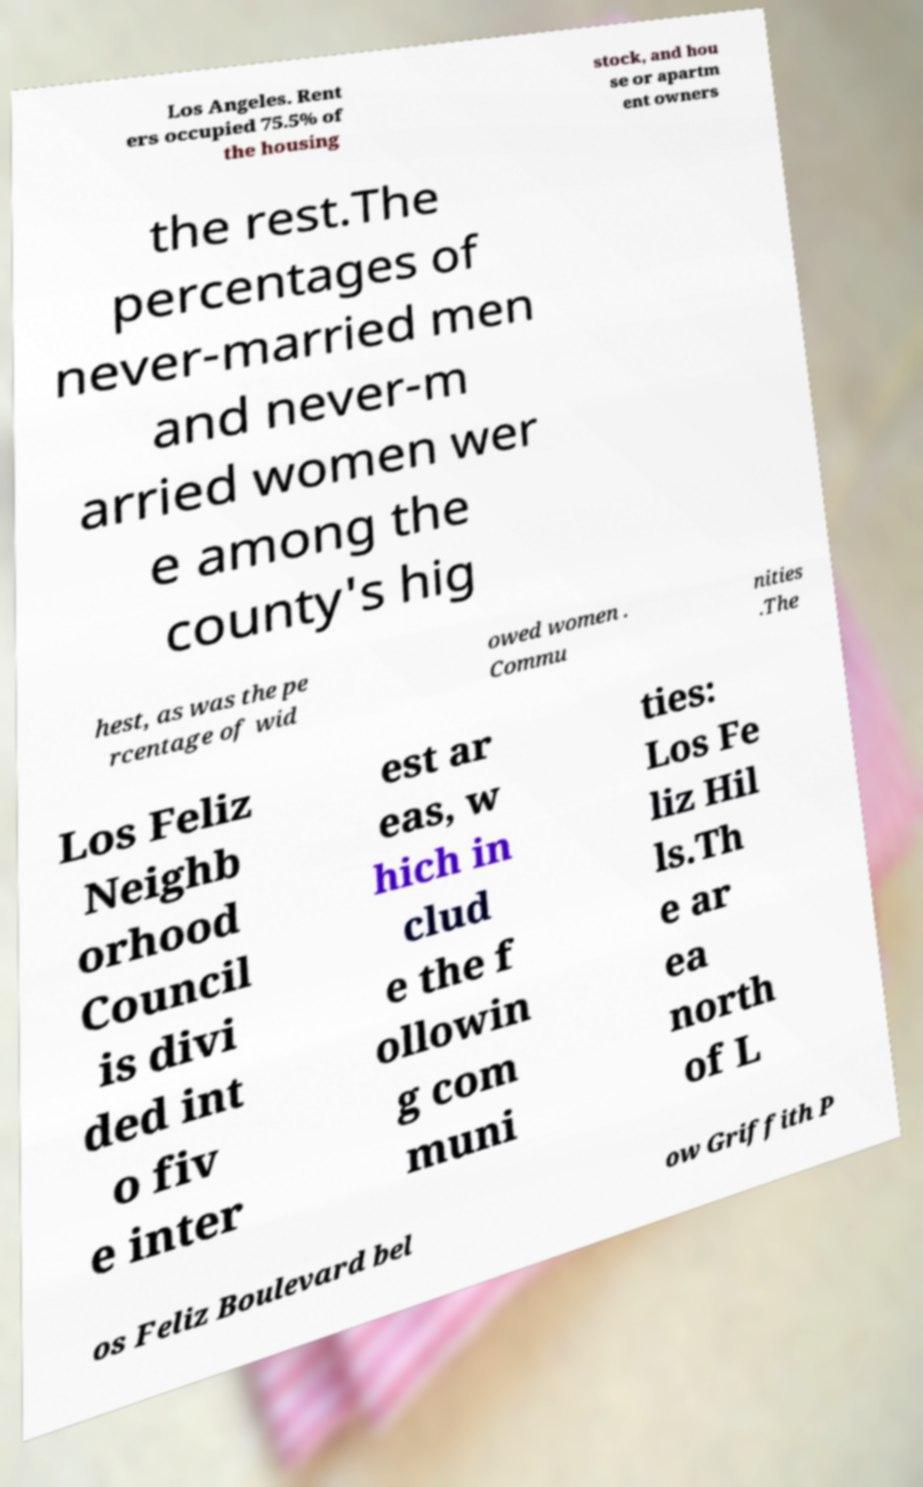I need the written content from this picture converted into text. Can you do that? Los Angeles. Rent ers occupied 75.5% of the housing stock, and hou se or apartm ent owners the rest.The percentages of never-married men and never-m arried women wer e among the county's hig hest, as was the pe rcentage of wid owed women . Commu nities .The Los Feliz Neighb orhood Council is divi ded int o fiv e inter est ar eas, w hich in clud e the f ollowin g com muni ties: Los Fe liz Hil ls.Th e ar ea north of L os Feliz Boulevard bel ow Griffith P 